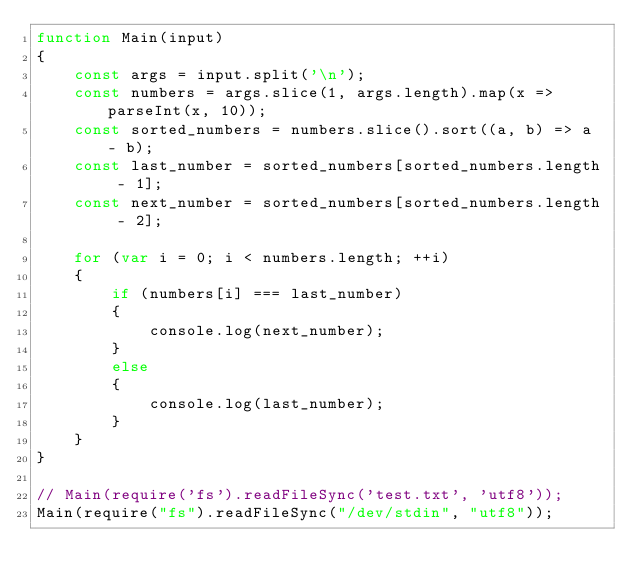<code> <loc_0><loc_0><loc_500><loc_500><_JavaScript_>function Main(input)
{
    const args = input.split('\n');
    const numbers = args.slice(1, args.length).map(x => parseInt(x, 10));
    const sorted_numbers = numbers.slice().sort((a, b) => a - b);
    const last_number = sorted_numbers[sorted_numbers.length - 1];
    const next_number = sorted_numbers[sorted_numbers.length - 2];

    for (var i = 0; i < numbers.length; ++i)
    {
        if (numbers[i] === last_number)
        {
            console.log(next_number);
        }
        else
        {
            console.log(last_number);
        }
    }
}

// Main(require('fs').readFileSync('test.txt', 'utf8'));
Main(require("fs").readFileSync("/dev/stdin", "utf8"));
</code> 